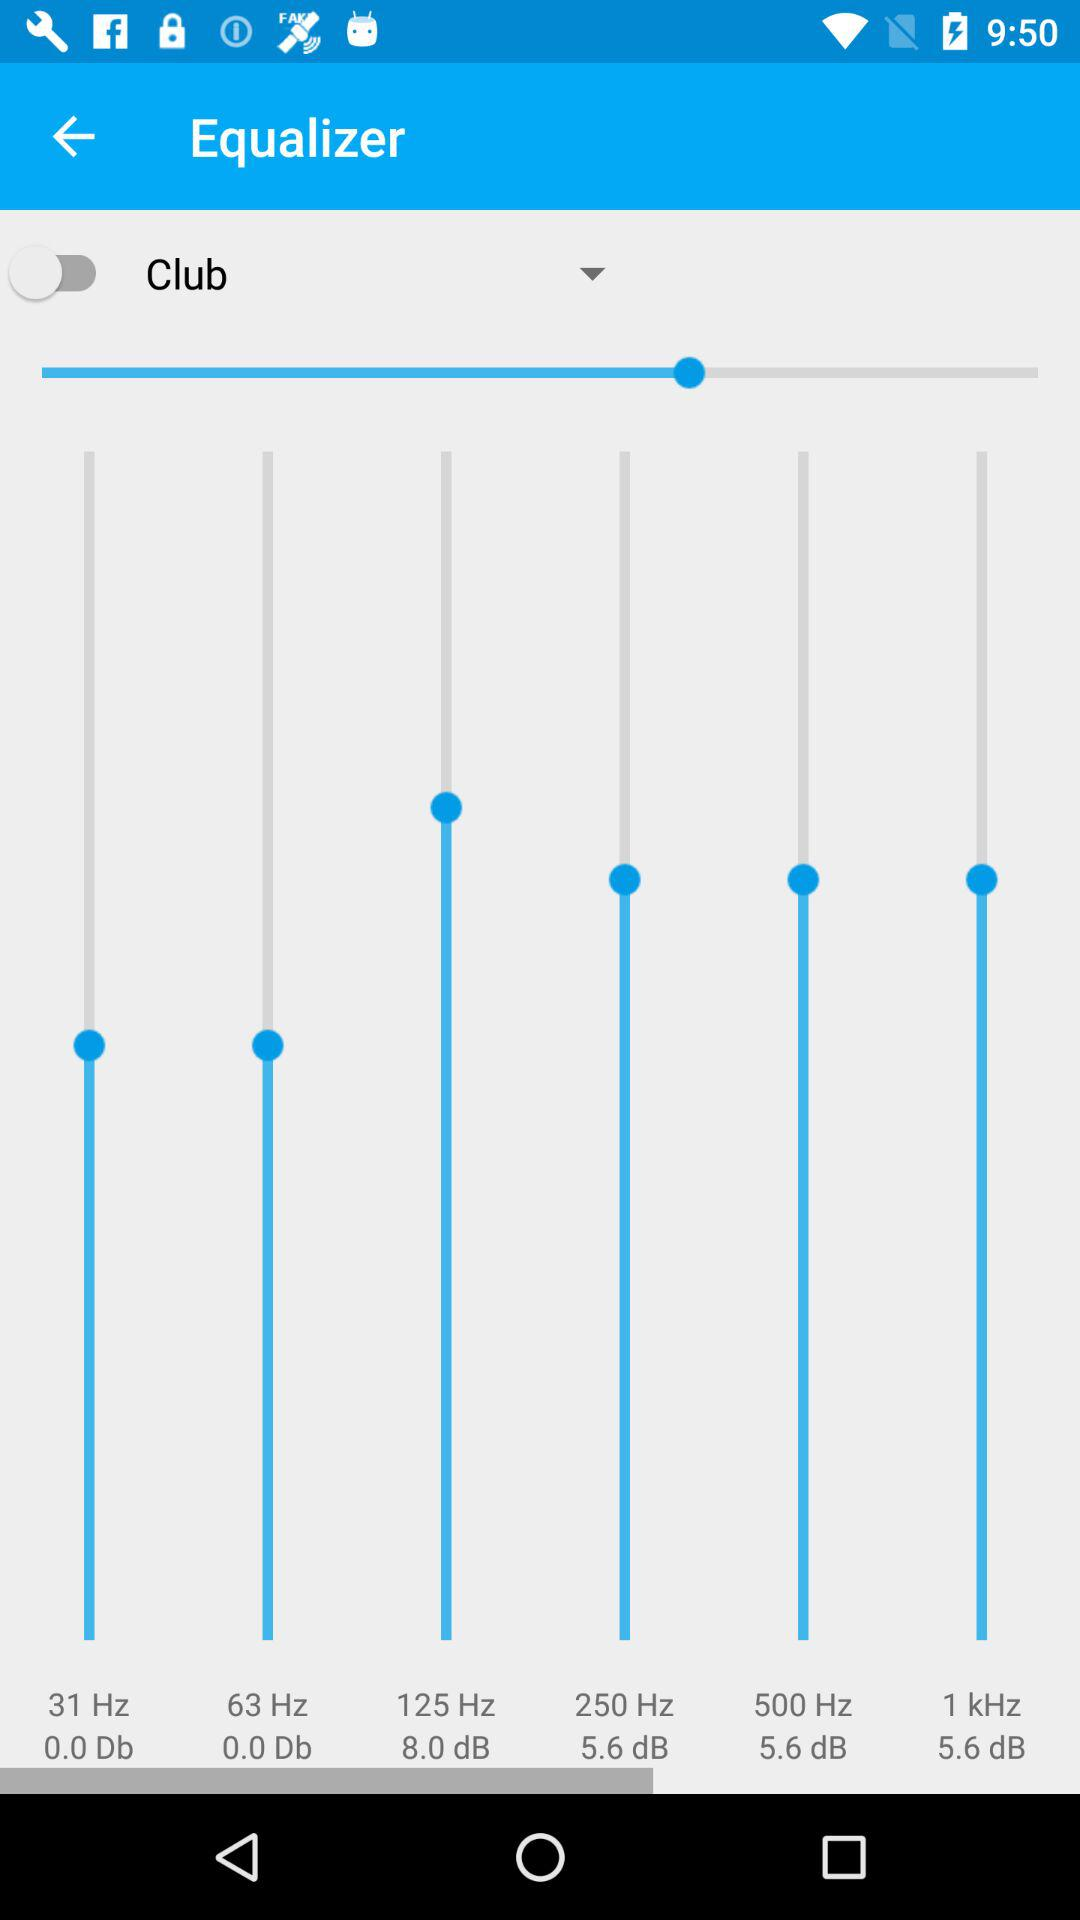How many frequency bands are there?
Answer the question using a single word or phrase. 6 